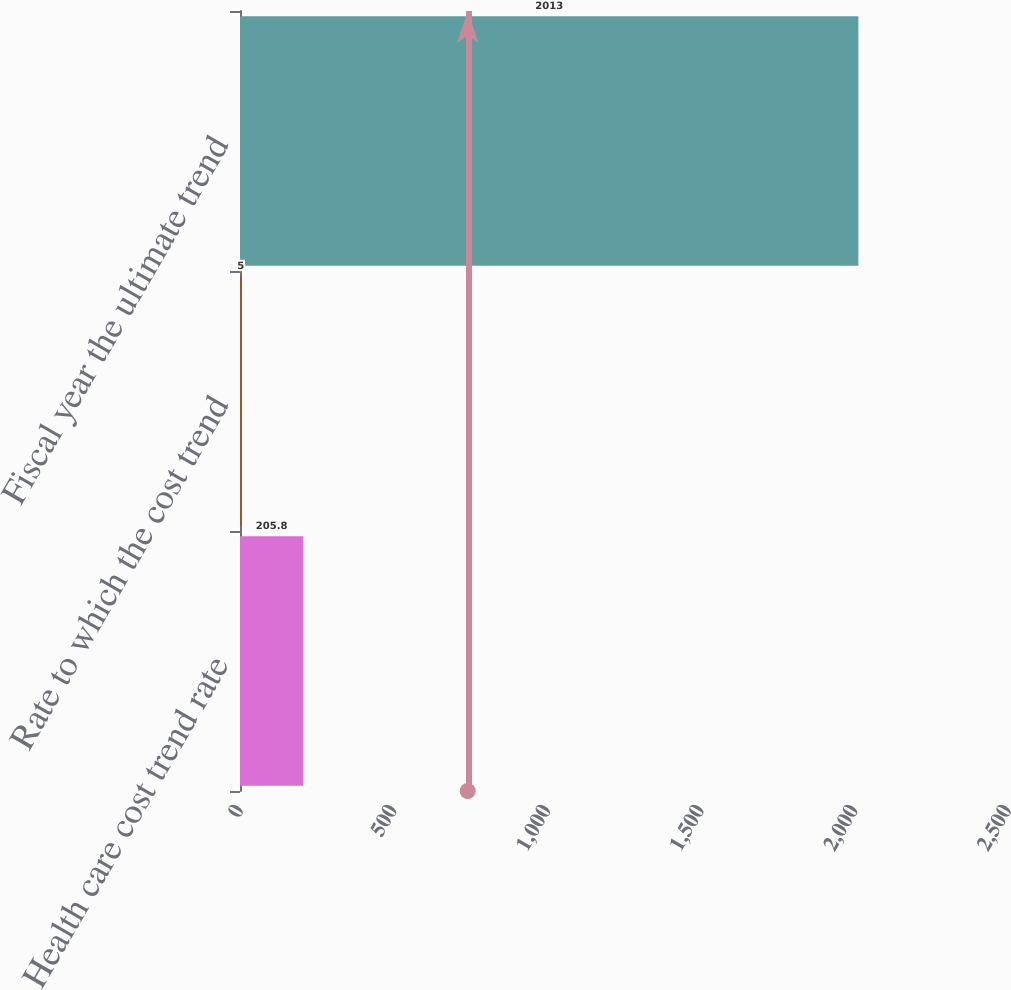Convert chart to OTSL. <chart><loc_0><loc_0><loc_500><loc_500><bar_chart><fcel>Health care cost trend rate<fcel>Rate to which the cost trend<fcel>Fiscal year the ultimate trend<nl><fcel>205.8<fcel>5<fcel>2013<nl></chart> 